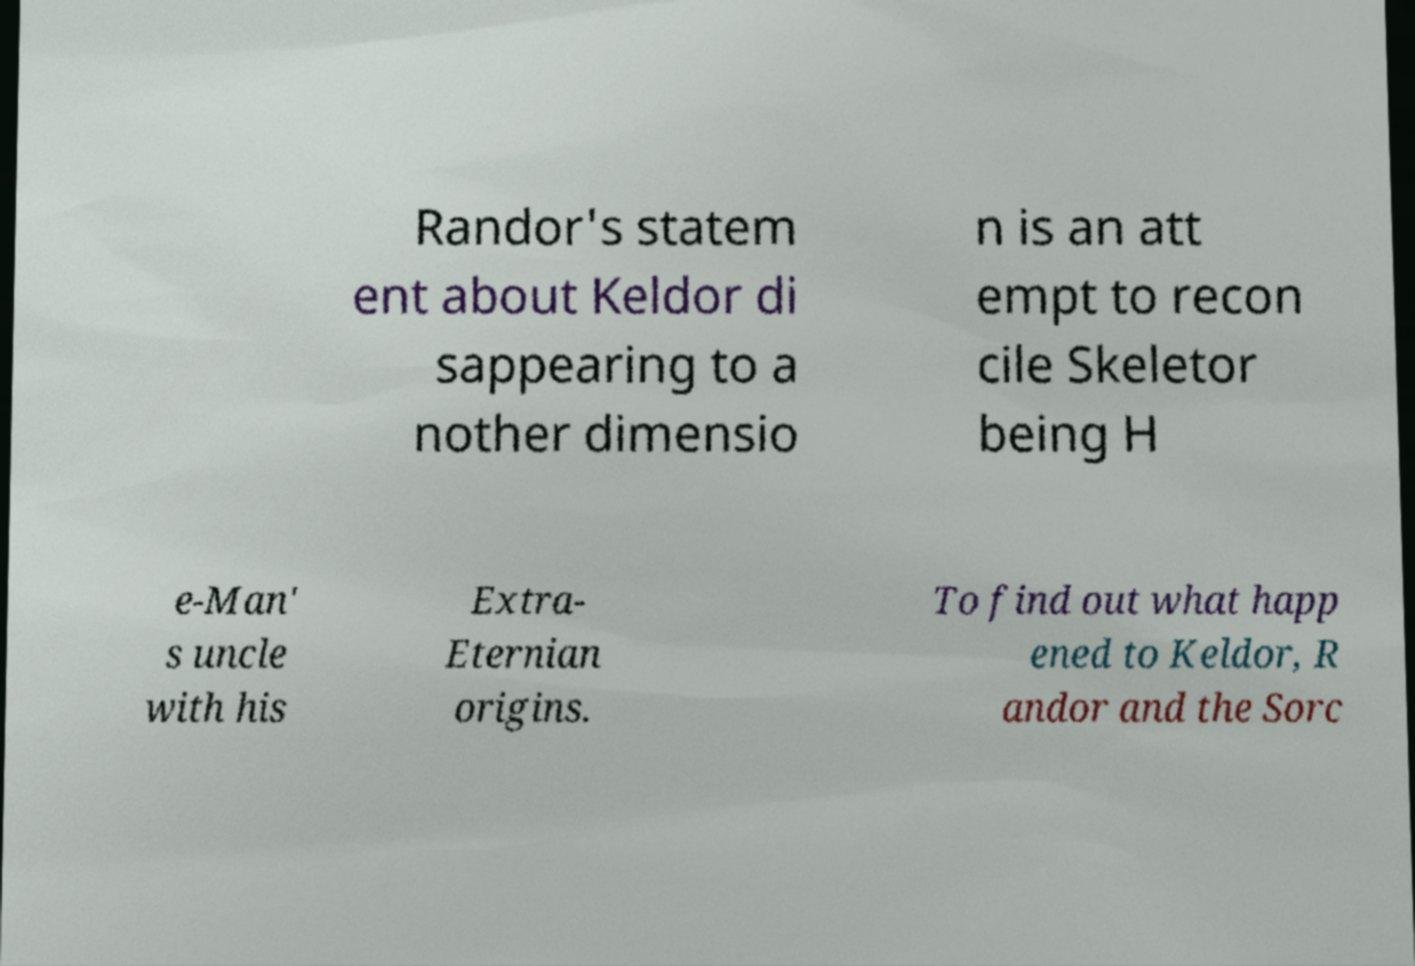Can you read and provide the text displayed in the image?This photo seems to have some interesting text. Can you extract and type it out for me? Randor's statem ent about Keldor di sappearing to a nother dimensio n is an att empt to recon cile Skeletor being H e-Man' s uncle with his Extra- Eternian origins. To find out what happ ened to Keldor, R andor and the Sorc 